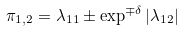Convert formula to latex. <formula><loc_0><loc_0><loc_500><loc_500>\pi _ { 1 , 2 } = \lambda _ { 1 1 } \pm \exp ^ { \mp \delta } | \lambda _ { 1 2 } |</formula> 